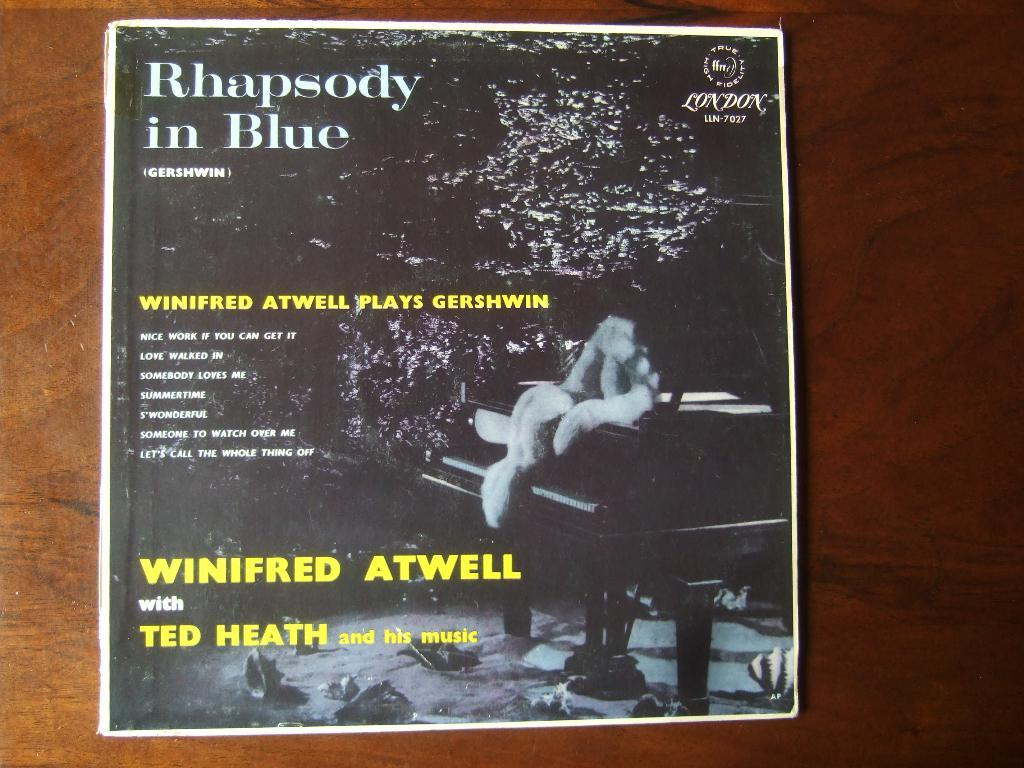<image>
Provide a brief description of the given image. An old album cover for an album named Rhapsody in Blue 